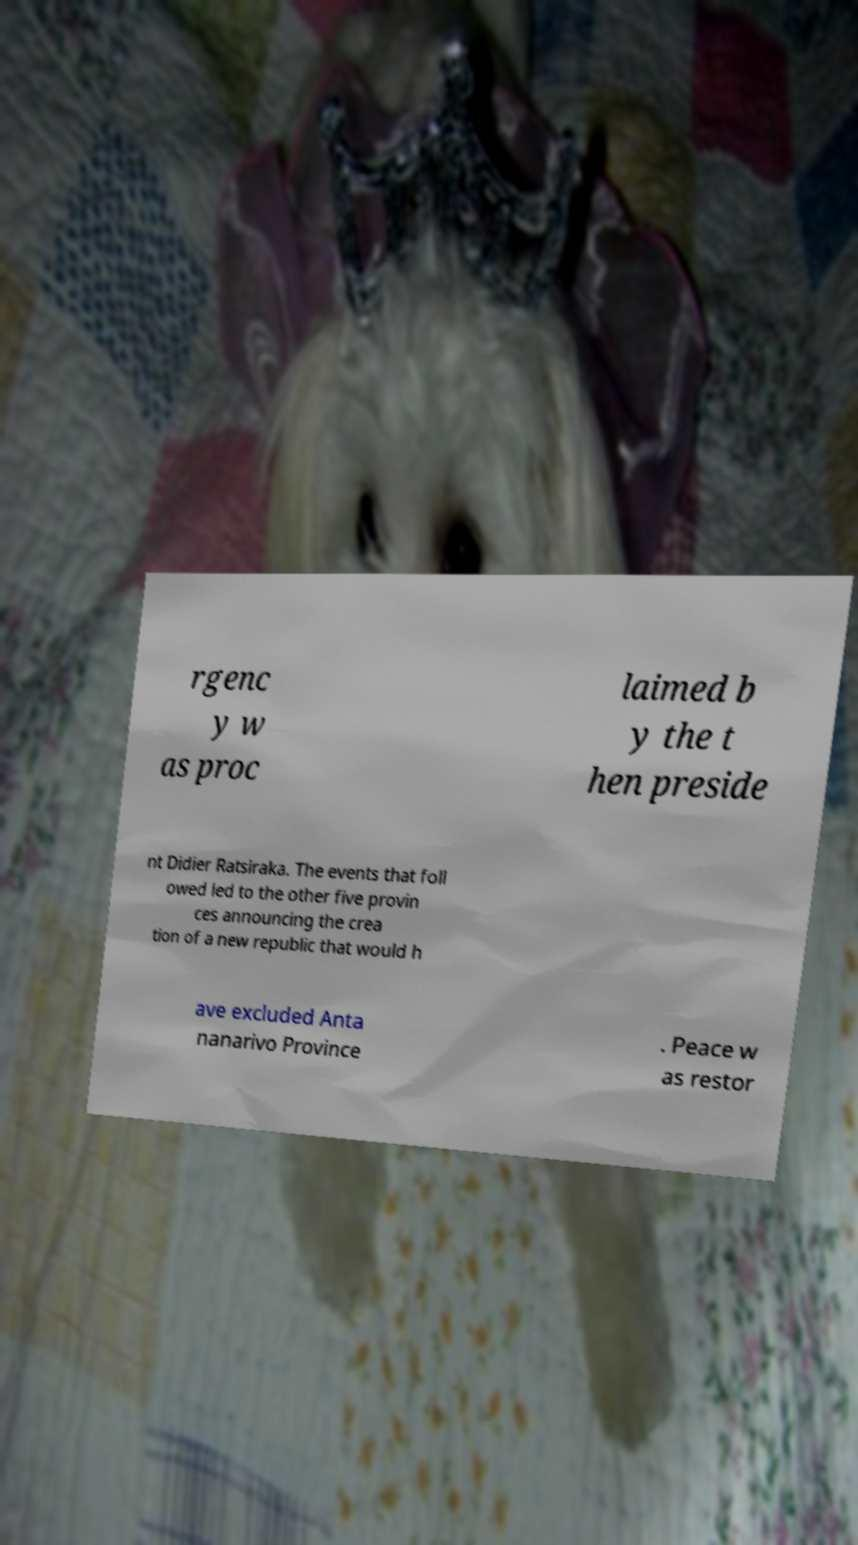For documentation purposes, I need the text within this image transcribed. Could you provide that? rgenc y w as proc laimed b y the t hen preside nt Didier Ratsiraka. The events that foll owed led to the other five provin ces announcing the crea tion of a new republic that would h ave excluded Anta nanarivo Province . Peace w as restor 